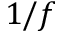Convert formula to latex. <formula><loc_0><loc_0><loc_500><loc_500>1 / f</formula> 